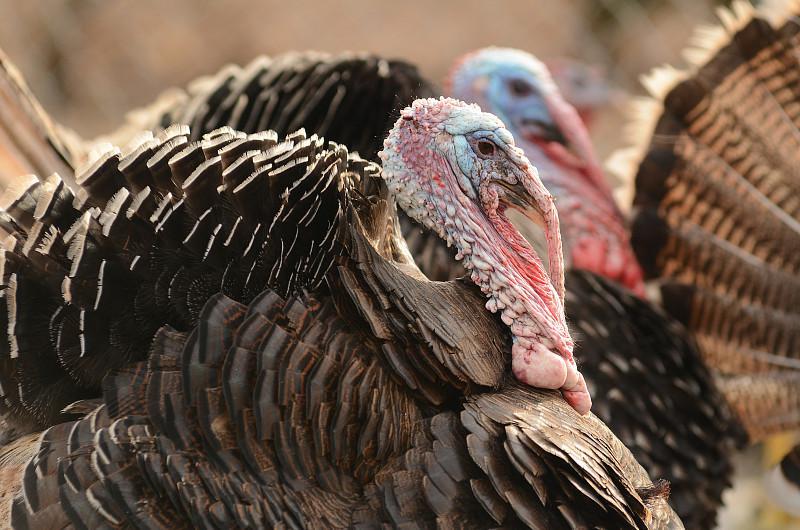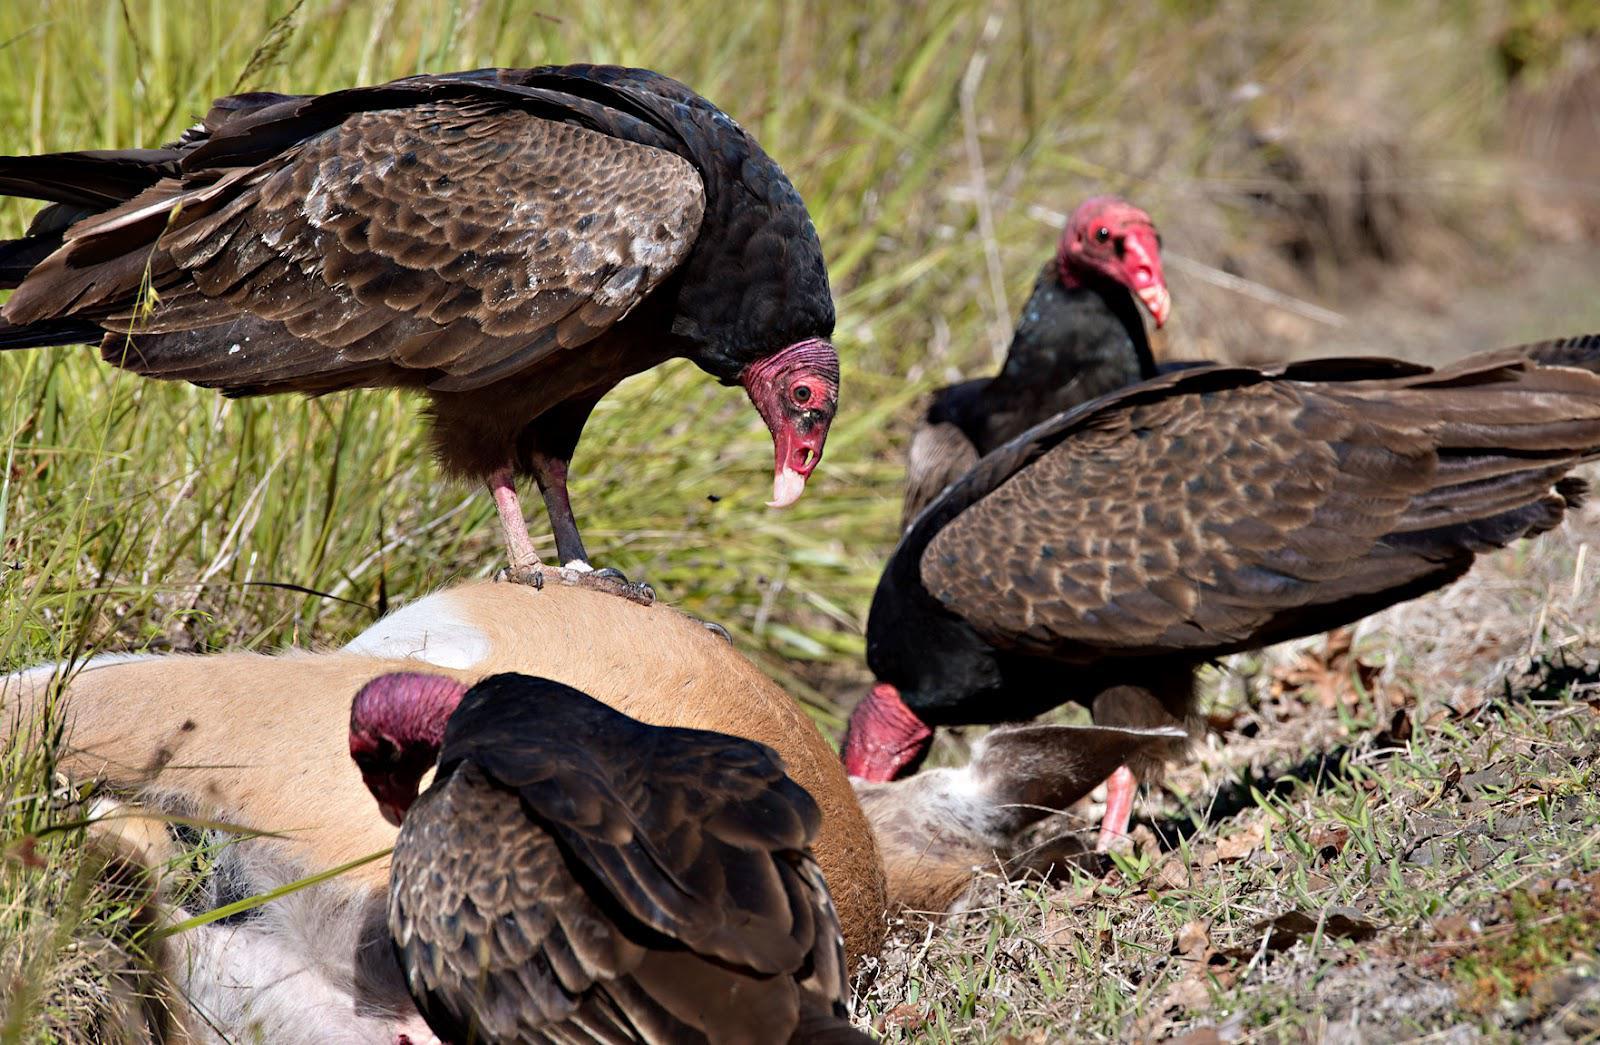The first image is the image on the left, the second image is the image on the right. Examine the images to the left and right. Is the description "At least one buzzard is standing on a dead animal in one of the images." accurate? Answer yes or no. Yes. The first image is the image on the left, the second image is the image on the right. For the images displayed, is the sentence "An image shows one vulture perched on a wooden limb." factually correct? Answer yes or no. No. 